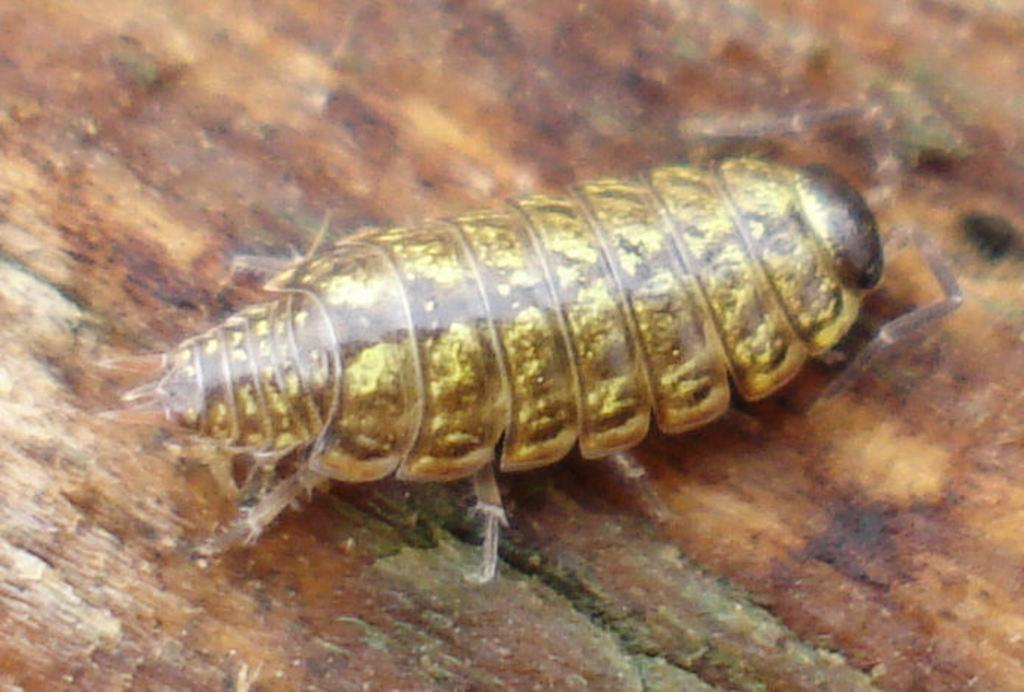What type of creature can be seen in the image? There is an insect in the image. What is the color of the insect? The insect is gold in color. What is the color of the background in the image? The background in the image is brown. What might the brown background represent? The brown background might be the stem of a tree. What type of voice does the insect have in the image? Insects do not have voices, so this question cannot be answered based on the image. 